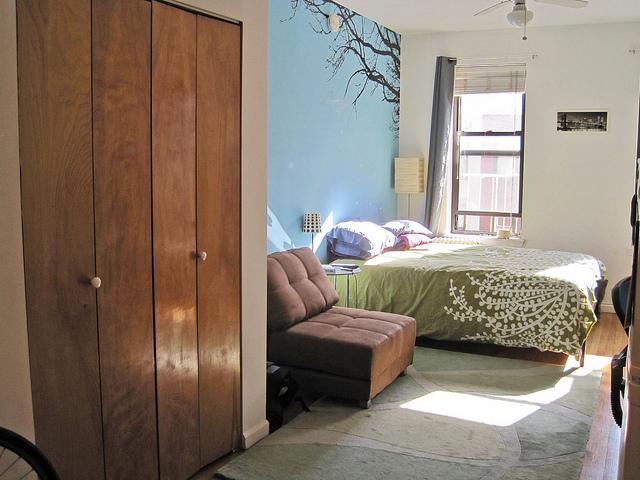What size is the bed?
Short answer required. Queen. What room is this?
Concise answer only. Bedroom. What is painted on the blue wall?
Short answer required. Tree branches. What is the green thing on the bed?
Keep it brief. Bedspread. What is the wooden flat object?
Give a very brief answer. Closet. What is the chair made of?
Short answer required. Fabric. What is the color of the sheet?
Concise answer only. Green. 